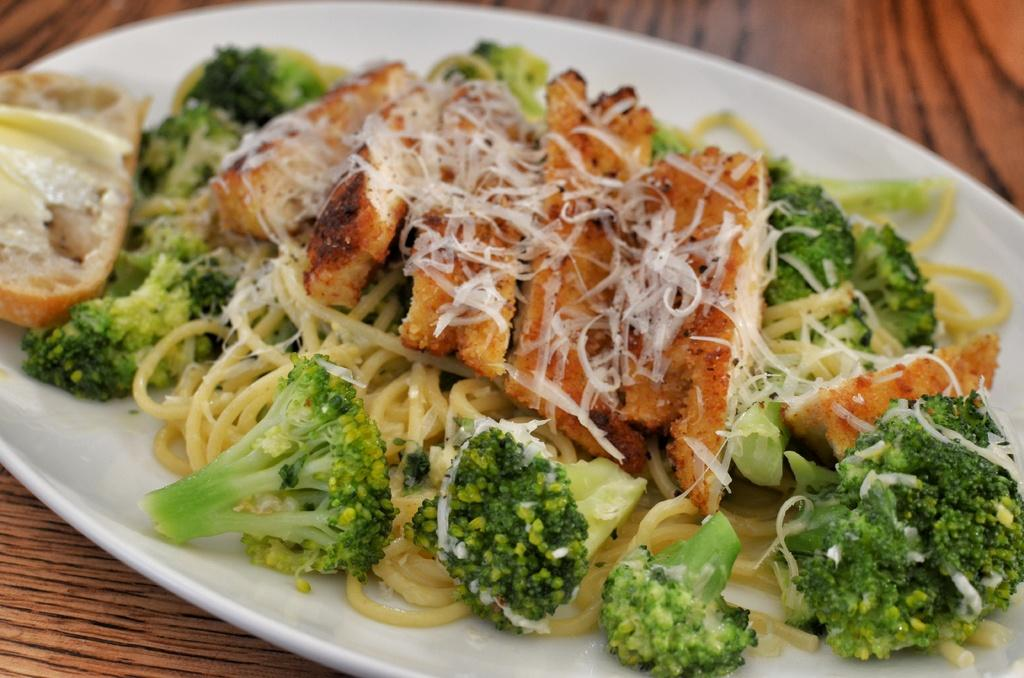What type of food can be seen in the image? There is bread, broccoli, noodles, and cheese in the image. How are the food items arranged in the image? The food items are on a plate in the image. Where is the plate with the food items located? The plate is placed on a table in the image. How many toes can be seen on the plate in the image? There are no toes present in the image; it features food items on a plate. What color is the eye of the person holding the plate in the image? There is no person holding the plate in the image; it is placed on a table. 